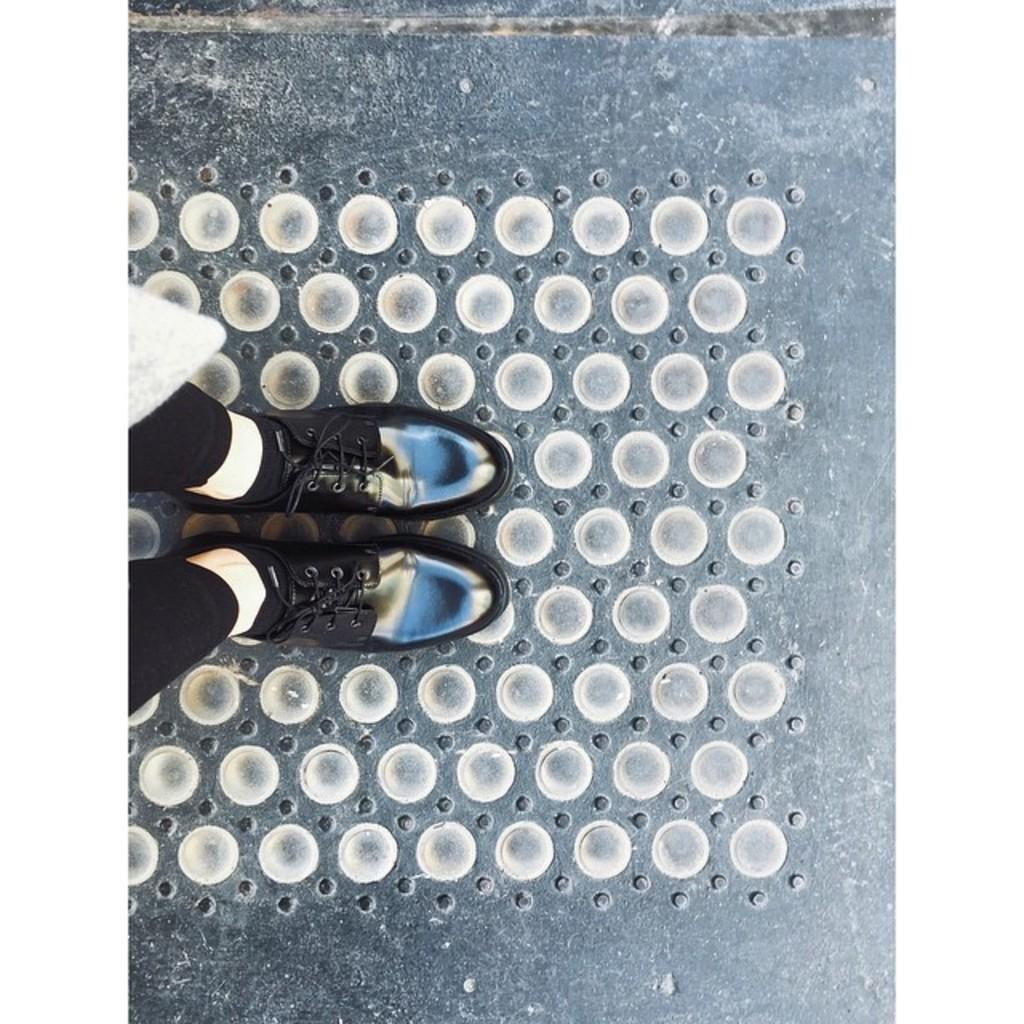In one or two sentences, can you explain what this image depicts? In this image I can see legs of a person. I can see this person is wearing black colour pant, black socks and black shoes. I can also see number of round things on the ground. 